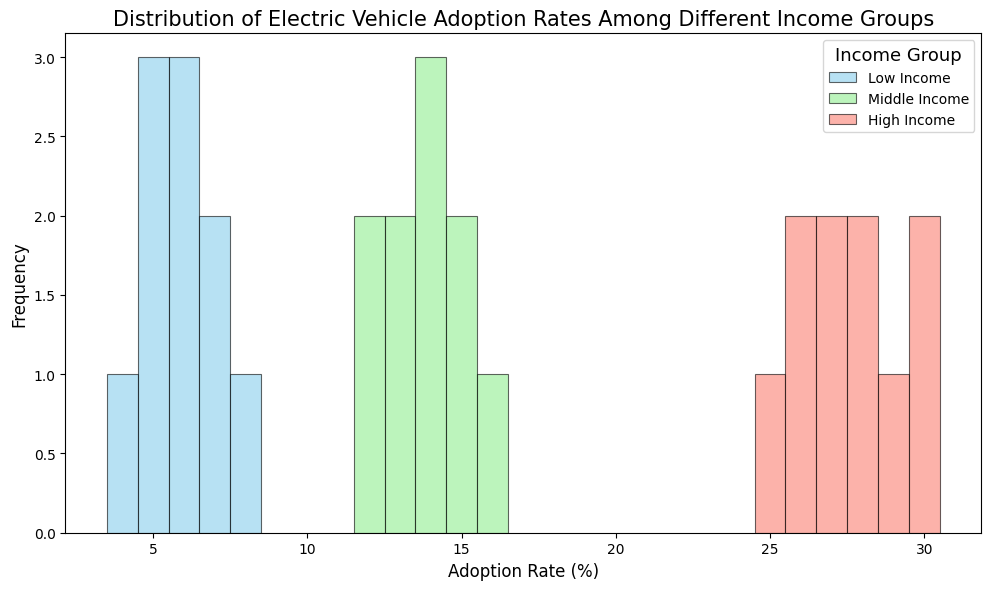What's the most common adoption rate among high-income groups? The most frequent (mode) adoption rate can be seen from the highest bars in the histogram for high-income groups. In this group, joint values of 26, 27, 28, and 30 are the most common, each having the highest frequency.
Answer: 26, 27, 28, and 30 Which income group shows the widest range in adoption rates? The range is the difference between the maximum and minimum adoption rates in each group. For the low-income group, the range is 4 (min) to 8 (max) = 8 - 4 = 4. For the middle-income group, the range is 12 (min) to 16 (max) = 16 - 12 = 4. For the high-income group, the range is 25 (min) to 30 (max) = 30 - 25 = 5. The high-income group has the widest range.
Answer: High-income group What is the median adoption rate in the middle-income group? To find the median, we need to arrange the middle-income data in order. Sorted data: 12, 12, 13, 13, 14, 14, 14, 15, 15, 16. The median value is the average of the 5th and 6th values: (14 + 14) / 2 = 14. The median adoption rate for middle-income groups is 14.
Answer: 14 Which income group has the most variability in electric vehicle adoption rates? Variability can be inferred from the spread and range of adoption rates, taking into account the width of the histogram. The high-income group has the most variability; its adoption rates range from 25 to 30, indicating a wider spread.
Answer: High-income group In which income group is the adoption rate most concentrated around a single value? Concentration can be seen by identifying where a significant portion of data points lie within a narrow range. The middle-income group has many values clustered around 14, indicating data concentration.
Answer: Middle-income group Is the peak adoption rate higher in the middle-income or low-income group? Peak adoption rate refers to the highest (maximum) value present. For the middle-income group, the peak adoption rates are 15 and 16, while for the low-income group, it is 8. Comparing these, the middle-income group has a higher peak adoption rate.
Answer: Middle-income group Which income group's histogram shows the greatest number of different adoption rates? We can count the distinct bins on the histogram for each income group. Low-income group has 4 different rates (4, 5, 6, 7, 8), middle-income group has 5 rates (12, 13, 14, 15, 16), and high-income group has 6 rates (25, 26, 27, 28, 29, 30). The high-income group shows the greatest number of different adoption rates.
Answer: High-income group In the context of the figure, what does each bar represent? Each bar in the histogram represents the frequency of a specific adoption rate within an income group.
Answer: Frequency of adoption rates For which income group are the adoption rates most evenly distributed? Even distribution means the bars are almost of equal height. Observing the histogram, the low-income group's histogram shows bars of similar height (4 to 8 adoption rates), indicating a more even distribution.
Answer: Low-income group 